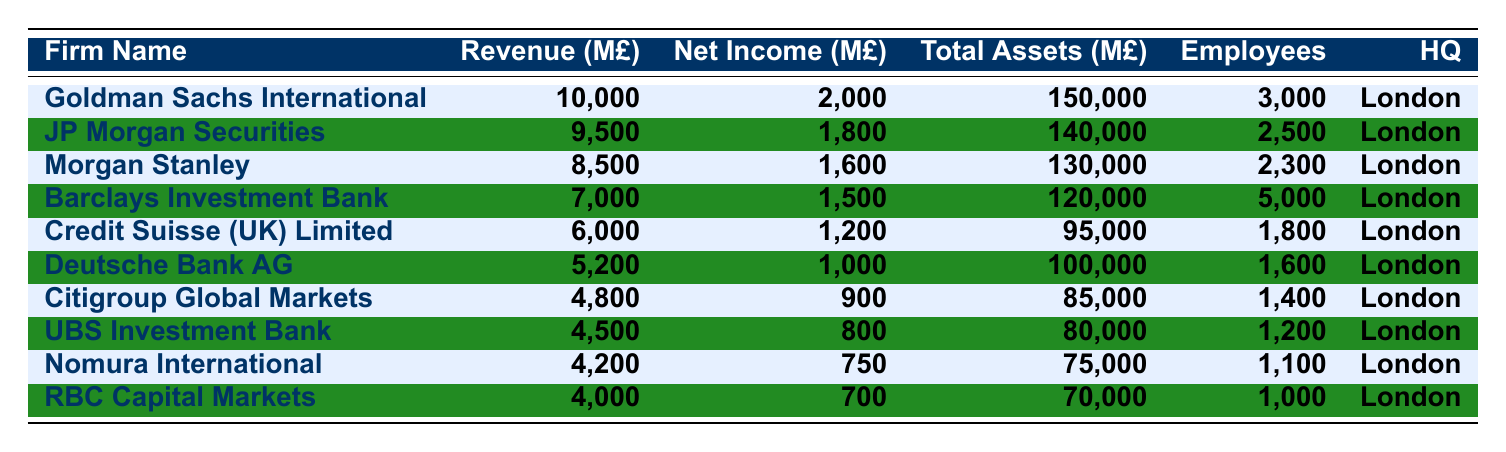What is the revenue of Goldman Sachs International? The revenue value for Goldman Sachs International is listed directly in the table under the revenue column, which shows it to be 10,000 million pounds.
Answer: 10,000 million pounds What is the total number of employees across all firms? To find the total number of employees, I will sum each firm's number of employees: 3000 + 2500 + 2300 + 5000 + 1800 + 1600 + 1400 + 1200 + 1100 + 1000 = 20,000.
Answer: 20,000 employees Which firm has the highest net income, and what is that amount? The firm with the highest net income is Goldman Sachs International, which has a net income of 2,000 million pounds as indicated in the net income column.
Answer: Goldman Sachs International, 2,000 million pounds Is the total assets for Deutsche Bank AG greater than that of RBC Capital Markets? The total assets for Deutsche Bank AG is 100,000 million pounds, while for RBC Capital Markets it is 70,000 million pounds. Since 100,000 is greater than 70,000, the statement is true.
Answer: Yes What is the average revenue of the listed firms? To calculate the average revenue, I first sum the revenues of all firms: 10,000 + 9,500 + 8,500 + 7,000 + 6,000 + 5,200 + 4,800 + 4,500 + 4,200 + 4,000 = 59,700 million pounds. Then, I divide by the number of firms (10), 59,700 / 10 = 5,970 million pounds.
Answer: 5,970 million pounds Which firm has the second lowest total assets, and what is that amount? The total assets for each firm can be compared to identify the second lowest. From the table, Nomura International has 75,000 million pounds and Citigroup Global Markets has 85,000 million pounds. Therefore, Citigroup has the second lowest total assets.
Answer: Citigroup Global Markets, 85,000 million pounds What is the difference in net income between JP Morgan Securities and Barclays Investment Bank? To find the difference in net income, I subtract Barclays Investment Bank's net income (1,500 million pounds) from JP Morgan Securities' net income (1,800 million pounds). This gives 1,800 - 1,500 = 300 million pounds difference.
Answer: 300 million pounds How many firms have a net income greater than 1,000 million pounds? By inspecting the net income figures, I can count firms with net incomes of 1,200, 1,500, 1,600, 1,800, and 2,000 million pounds: (Credit Suisse, Barclays, Morgan Stanley, JP Morgan, Goldman Sachs). Therefore, there are 5 firms exceeding 1,000 million pounds.
Answer: 5 firms Which firm has the lowest revenue, and what is that revenue? Comparing the revenue figures, RBC Capital Markets has the lowest revenue at 4,000 million pounds as shown in the revenue column of the table.
Answer: RBC Capital Markets, 4,000 million pounds What percentage of total employees does Goldman Sachs International represent? First, I note the total number of employees is 20,000. Goldman Sachs has 3,000 employees. The percentage is calculated as (3,000 / 20,000) * 100, which equals 15%.
Answer: 15% 